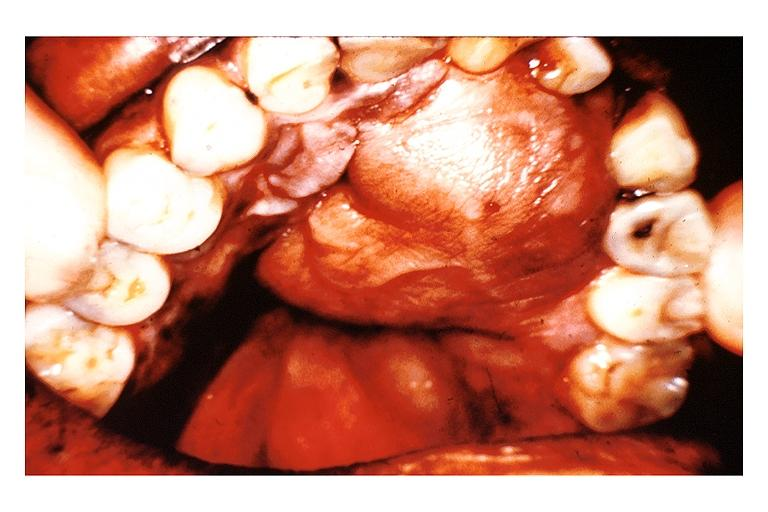what is present?
Answer the question using a single word or phrase. Oral 